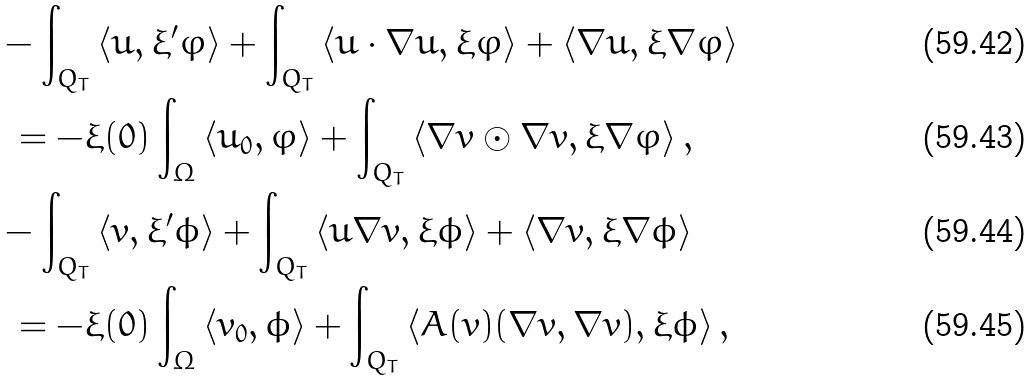<formula> <loc_0><loc_0><loc_500><loc_500>& - \int _ { Q _ { T } } \left \langle u , \xi ^ { \prime } \varphi \right \rangle + \int _ { Q _ { T } } \left \langle u \cdot \nabla u , \xi \varphi \right \rangle + \left \langle \nabla u , \xi \nabla \varphi \right \rangle \\ & \ = - \xi ( 0 ) \int _ { \Omega } \left \langle u _ { 0 } , \varphi \right \rangle + \int _ { Q _ { T } } \left \langle \nabla v \odot \nabla v , \xi \nabla \varphi \right \rangle , \\ & - \int _ { Q _ { T } } \left \langle v , \xi ^ { \prime } \phi \right \rangle + \int _ { Q _ { T } } \left \langle u \nabla v , \xi \phi \right \rangle + \left \langle \nabla v , \xi \nabla \phi \right \rangle \\ & \ = - \xi ( 0 ) \int _ { \Omega } \left \langle v _ { 0 } , \phi \right \rangle + \int _ { Q _ { T } } \left \langle A ( v ) ( \nabla v , \nabla v ) , \xi \phi \right \rangle ,</formula> 